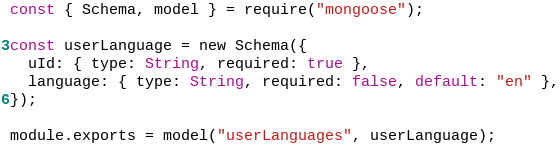<code> <loc_0><loc_0><loc_500><loc_500><_JavaScript_>const { Schema, model } = require("mongoose");

const userLanguage = new Schema({
  uId: { type: String, required: true },
  language: { type: String, required: false, default: "en" },
});

module.exports = model("userLanguages", userLanguage);
</code> 